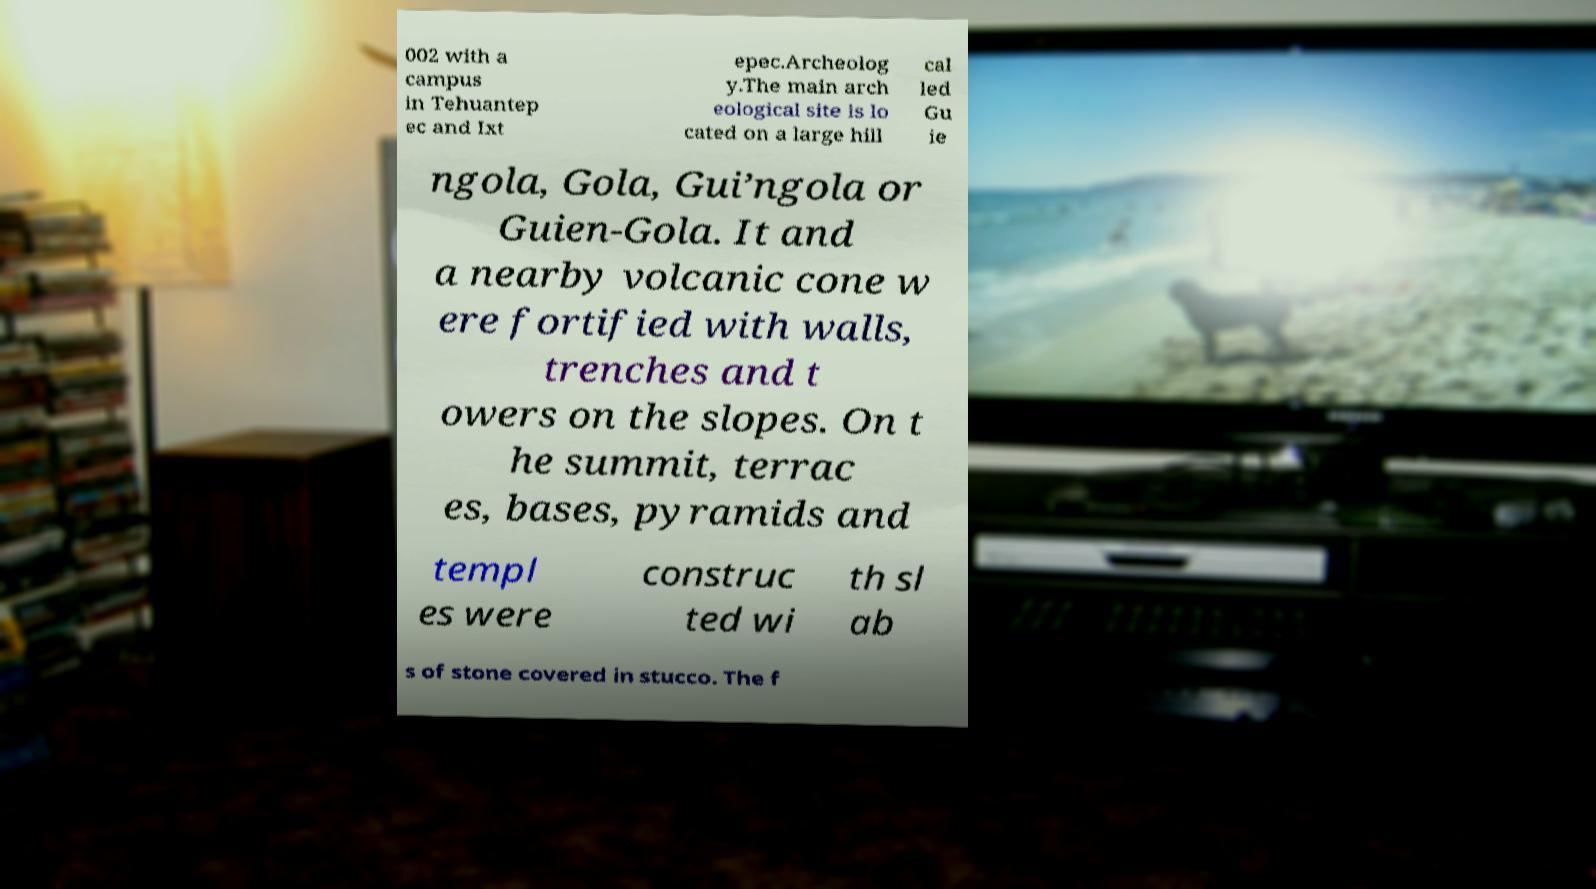Can you read and provide the text displayed in the image?This photo seems to have some interesting text. Can you extract and type it out for me? 002 with a campus in Tehuantep ec and Ixt epec.Archeolog y.The main arch eological site is lo cated on a large hill cal led Gu ie ngola, Gola, Gui’ngola or Guien-Gola. It and a nearby volcanic cone w ere fortified with walls, trenches and t owers on the slopes. On t he summit, terrac es, bases, pyramids and templ es were construc ted wi th sl ab s of stone covered in stucco. The f 